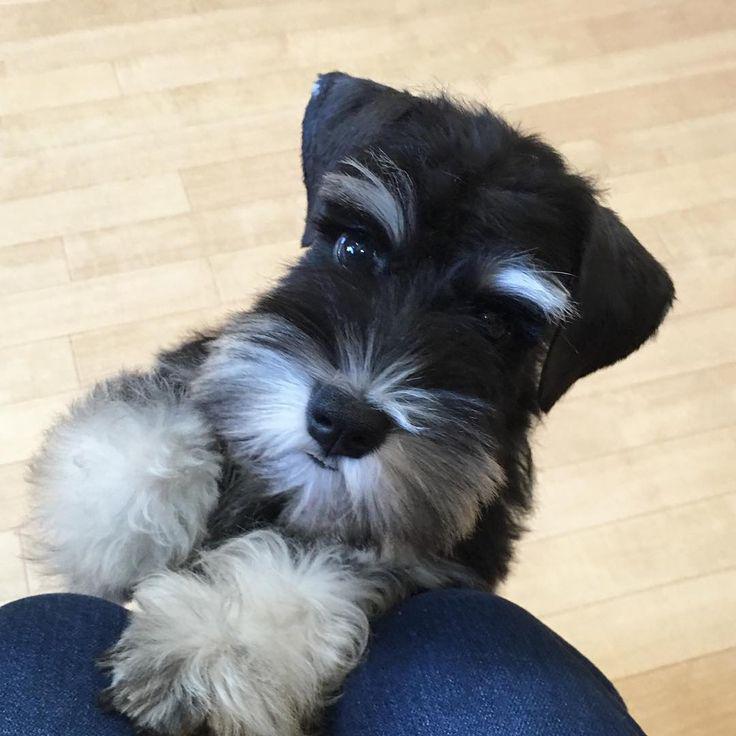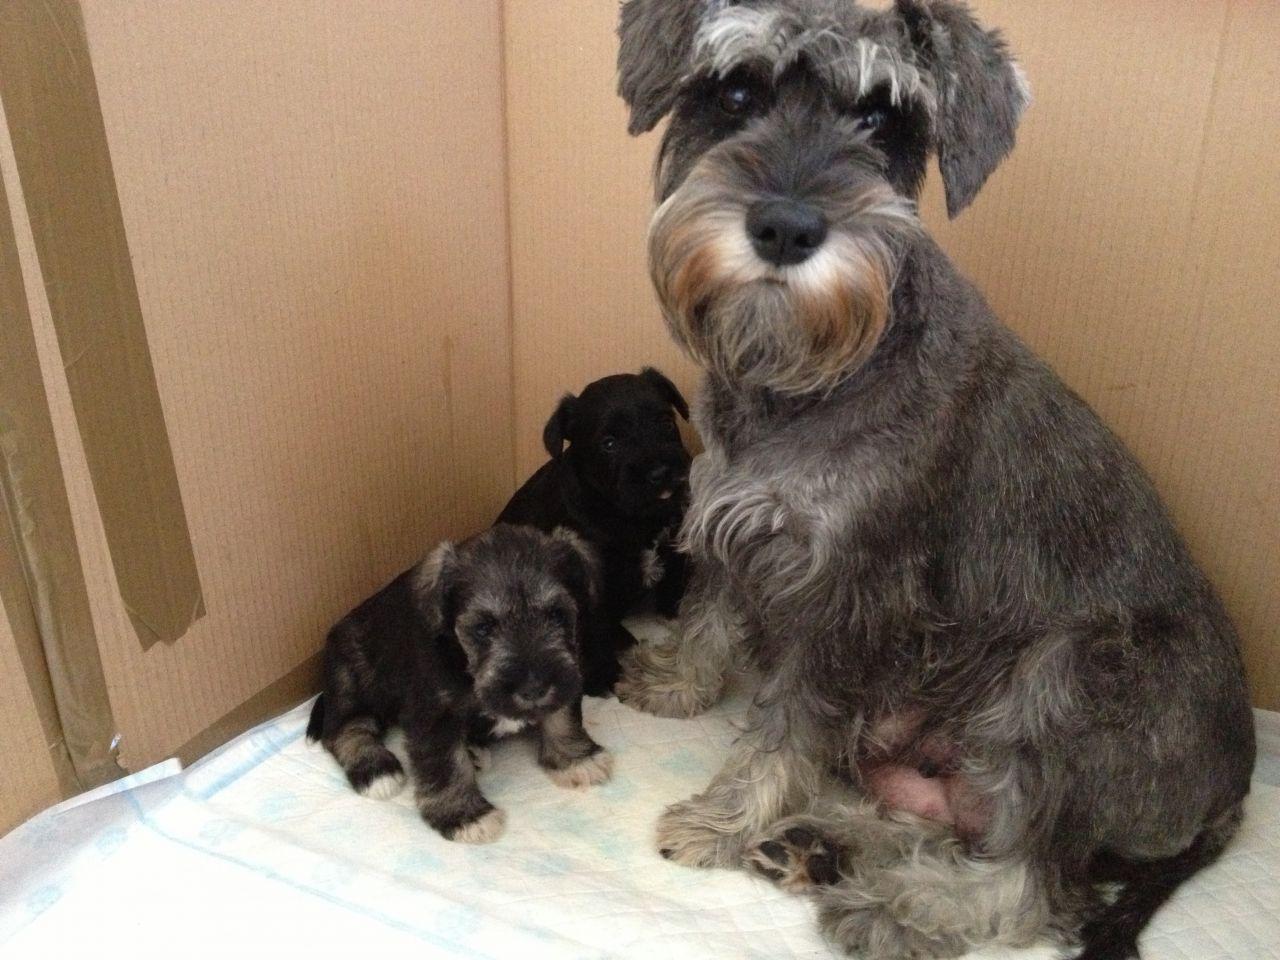The first image is the image on the left, the second image is the image on the right. For the images shown, is this caption "All images show dogs outdoors with grass." true? Answer yes or no. No. The first image is the image on the left, the second image is the image on the right. Considering the images on both sides, is "In 1 of the images, 1 dog has an object in its mouth." valid? Answer yes or no. No. 